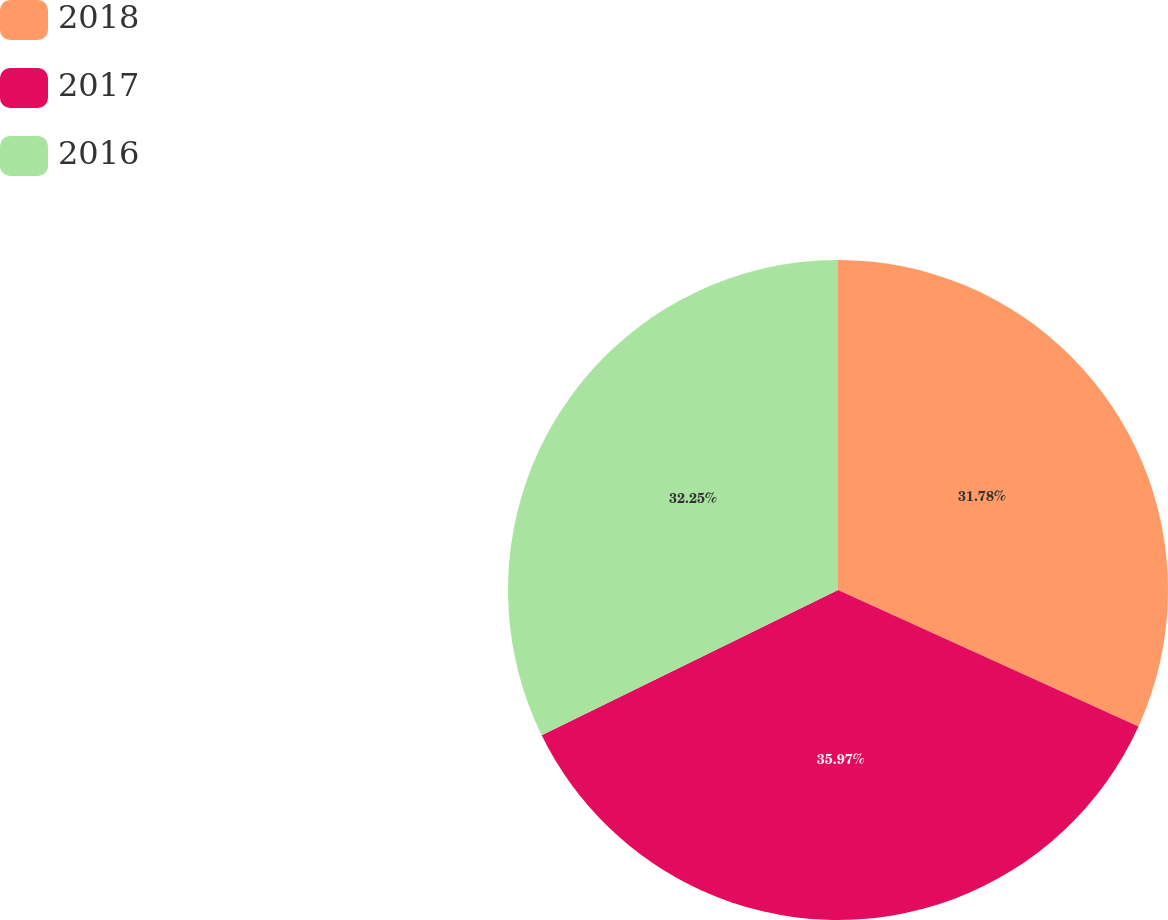<chart> <loc_0><loc_0><loc_500><loc_500><pie_chart><fcel>2018<fcel>2017<fcel>2016<nl><fcel>31.78%<fcel>35.96%<fcel>32.25%<nl></chart> 